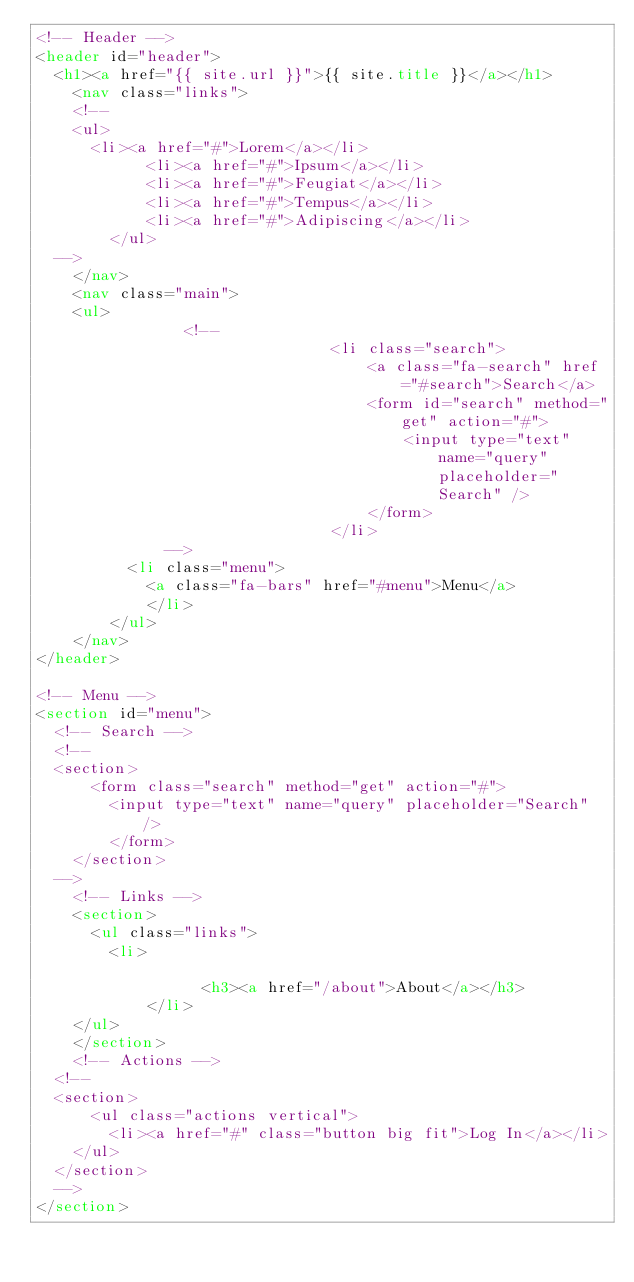Convert code to text. <code><loc_0><loc_0><loc_500><loc_500><_HTML_><!-- Header -->
<header id="header">
  <h1><a href="{{ site.url }}">{{ site.title }}</a></h1>
	<nav class="links">
    <!--
    <ul>
      <li><a href="#">Lorem</a></li>
			<li><a href="#">Ipsum</a></li>
			<li><a href="#">Feugiat</a></li>
			<li><a href="#">Tempus</a></li>
			<li><a href="#">Adipiscing</a></li>
		</ul>
  -->
	</nav>
	<nav class="main">
    <ul>
                <!--
								<li class="search">
									<a class="fa-search" href="#search">Search</a>
									<form id="search" method="get" action="#">
										<input type="text" name="query" placeholder="Search" />
									</form>
								</li>
              -->
		  <li class="menu">
		  	<a class="fa-bars" href="#menu">Menu</a>
			</li>
		</ul>
	</nav>
</header>

<!-- Menu -->
<section id="menu">
  <!-- Search -->
  <!--
  <section>
	  <form class="search" method="get" action="#">
	    <input type="text" name="query" placeholder="Search" />
		</form>
	</section>
  -->
	<!-- Links -->
	<section>
	  <ul class="links">
	    <li>
		    
				  <h3><a href="/about">About</a></h3>
			</li>
    </ul>
	</section>
	<!-- Actions -->
  <!--
  <section>
	  <ul class="actions vertical">
	    <li><a href="#" class="button big fit">Log In</a></li>
    </ul>
  </section>
  -->
</section>
</code> 